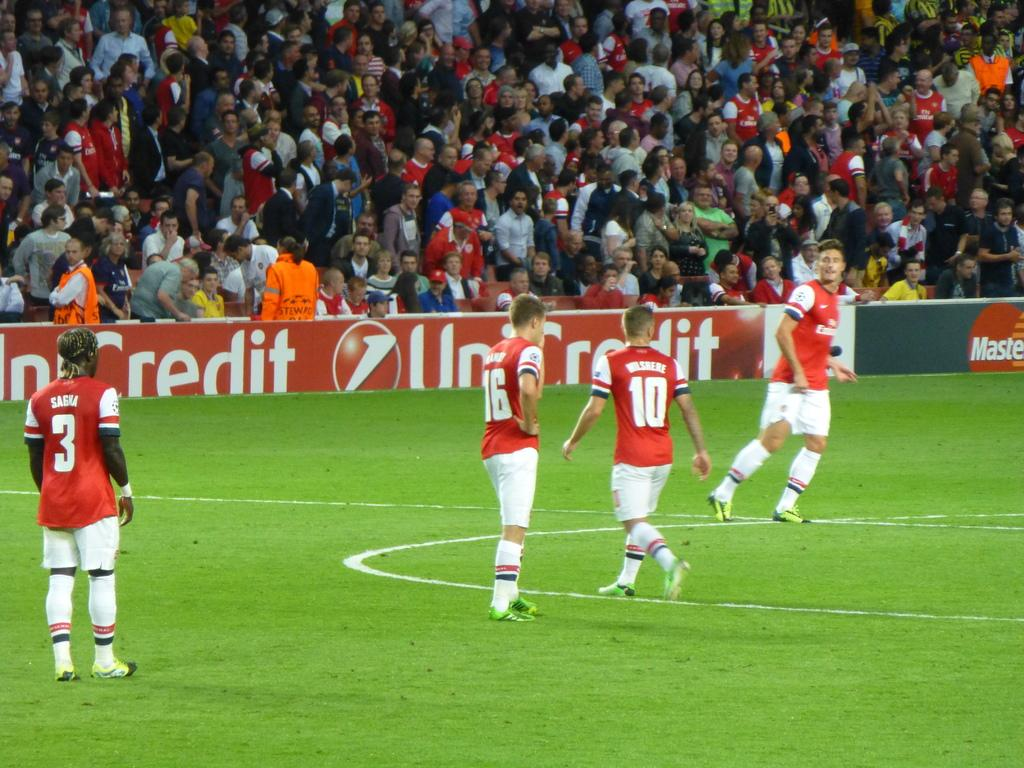<image>
Give a short and clear explanation of the subsequent image. Athletes in red jerseys, including #3, 16, and 10 are on a field that is sponsored by UniCredit. 